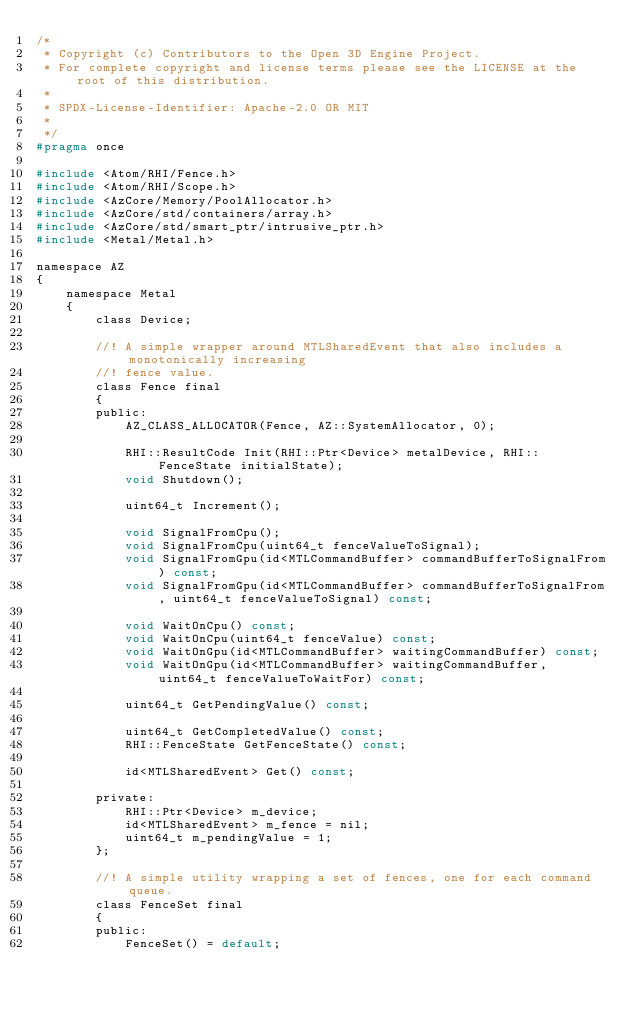Convert code to text. <code><loc_0><loc_0><loc_500><loc_500><_C_>/*
 * Copyright (c) Contributors to the Open 3D Engine Project.
 * For complete copyright and license terms please see the LICENSE at the root of this distribution.
 *
 * SPDX-License-Identifier: Apache-2.0 OR MIT
 *
 */
#pragma once

#include <Atom/RHI/Fence.h>
#include <Atom/RHI/Scope.h>
#include <AzCore/Memory/PoolAllocator.h>
#include <AzCore/std/containers/array.h>
#include <AzCore/std/smart_ptr/intrusive_ptr.h>
#include <Metal/Metal.h>

namespace AZ
{
    namespace Metal
    {
        class Device;

        //! A simple wrapper around MTLSharedEvent that also includes a monotonically increasing
        //! fence value.
        class Fence final
        {
        public:
            AZ_CLASS_ALLOCATOR(Fence, AZ::SystemAllocator, 0);

            RHI::ResultCode Init(RHI::Ptr<Device> metalDevice, RHI::FenceState initialState);
            void Shutdown();

            uint64_t Increment();

            void SignalFromCpu();
            void SignalFromCpu(uint64_t fenceValueToSignal);
            void SignalFromGpu(id<MTLCommandBuffer> commandBufferToSignalFrom) const;
            void SignalFromGpu(id<MTLCommandBuffer> commandBufferToSignalFrom, uint64_t fenceValueToSignal) const;

            void WaitOnCpu() const;
            void WaitOnCpu(uint64_t fenceValue) const;
            void WaitOnGpu(id<MTLCommandBuffer> waitingCommandBuffer) const;
            void WaitOnGpu(id<MTLCommandBuffer> waitingCommandBuffer, uint64_t fenceValueToWaitFor) const;

            uint64_t GetPendingValue() const;

            uint64_t GetCompletedValue() const;
            RHI::FenceState GetFenceState() const;

            id<MTLSharedEvent> Get() const;
            
        private:
            RHI::Ptr<Device> m_device;
            id<MTLSharedEvent> m_fence = nil;
            uint64_t m_pendingValue = 1;
        };

        //! A simple utility wrapping a set of fences, one for each command queue.
        class FenceSet final
        {
        public:
            FenceSet() = default;
</code> 